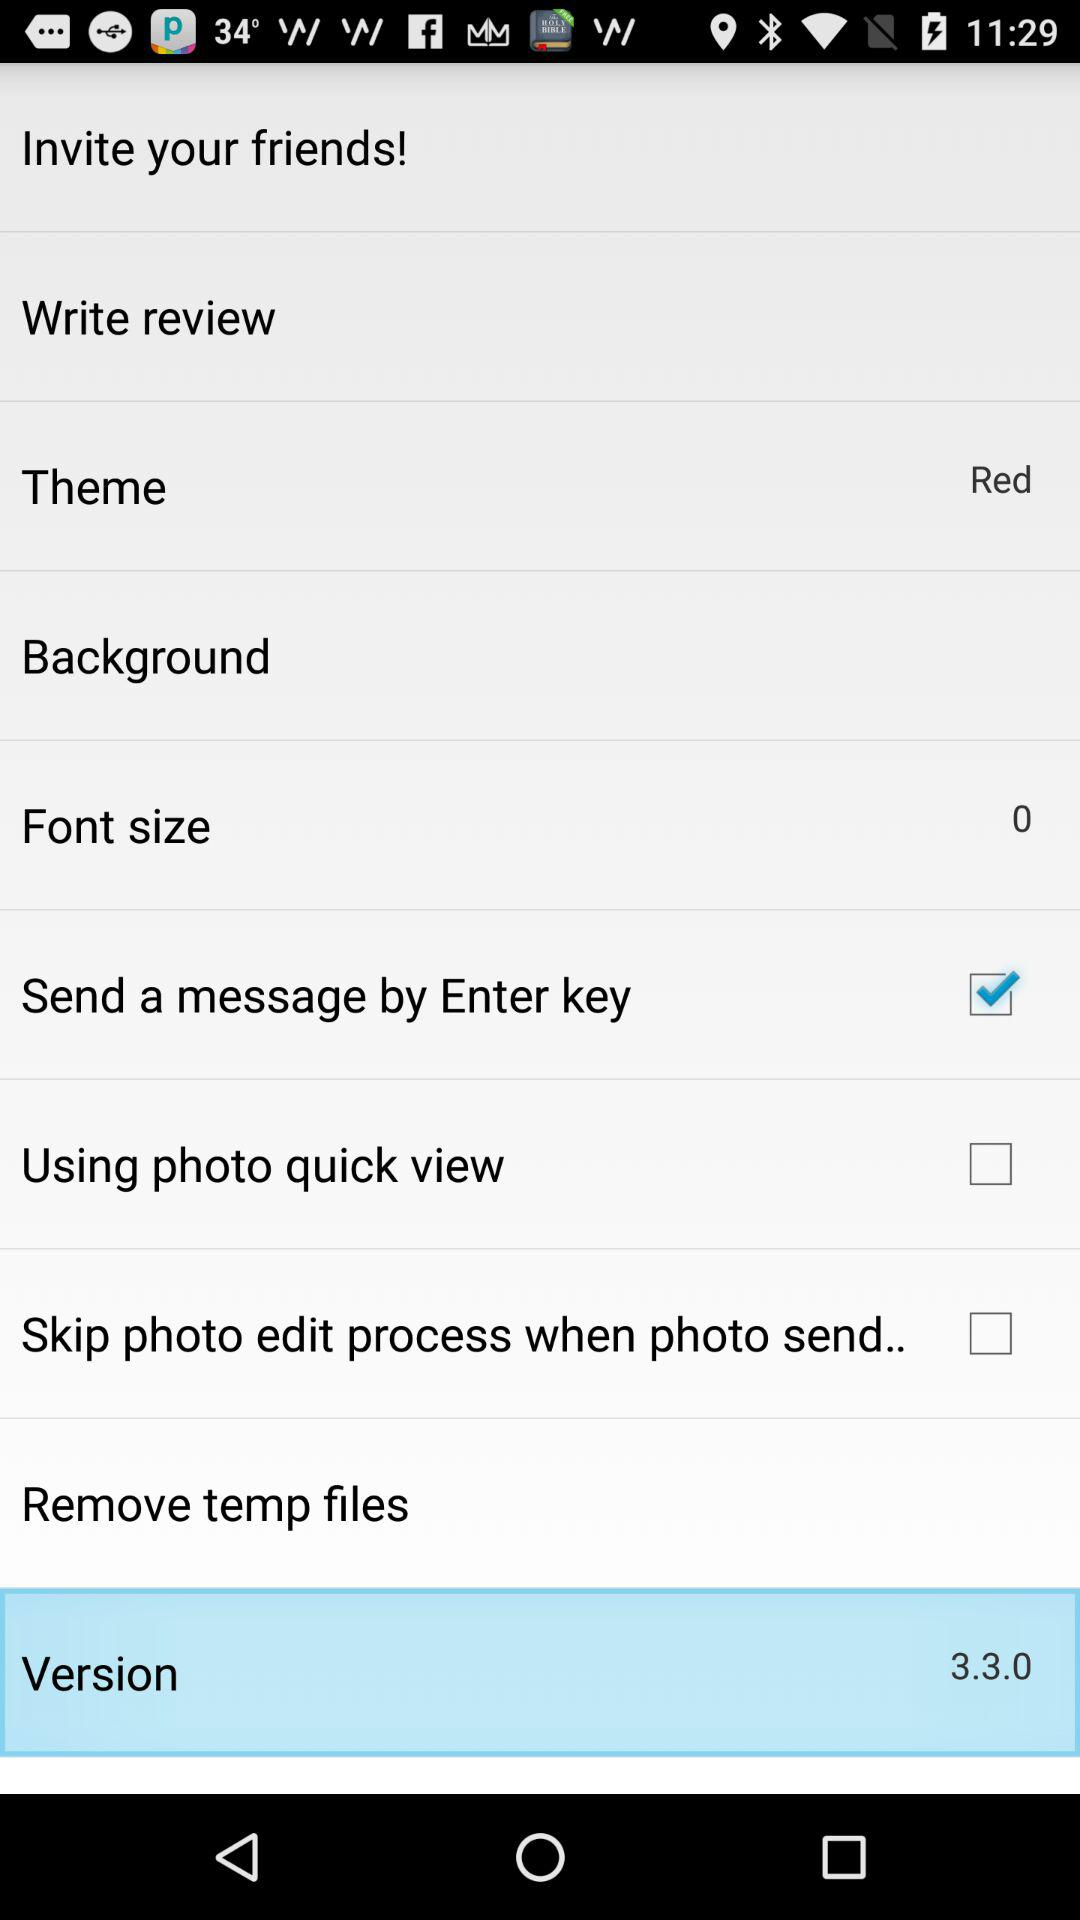How many items are there in the 'theme' section?
Answer the question using a single word or phrase. 2 